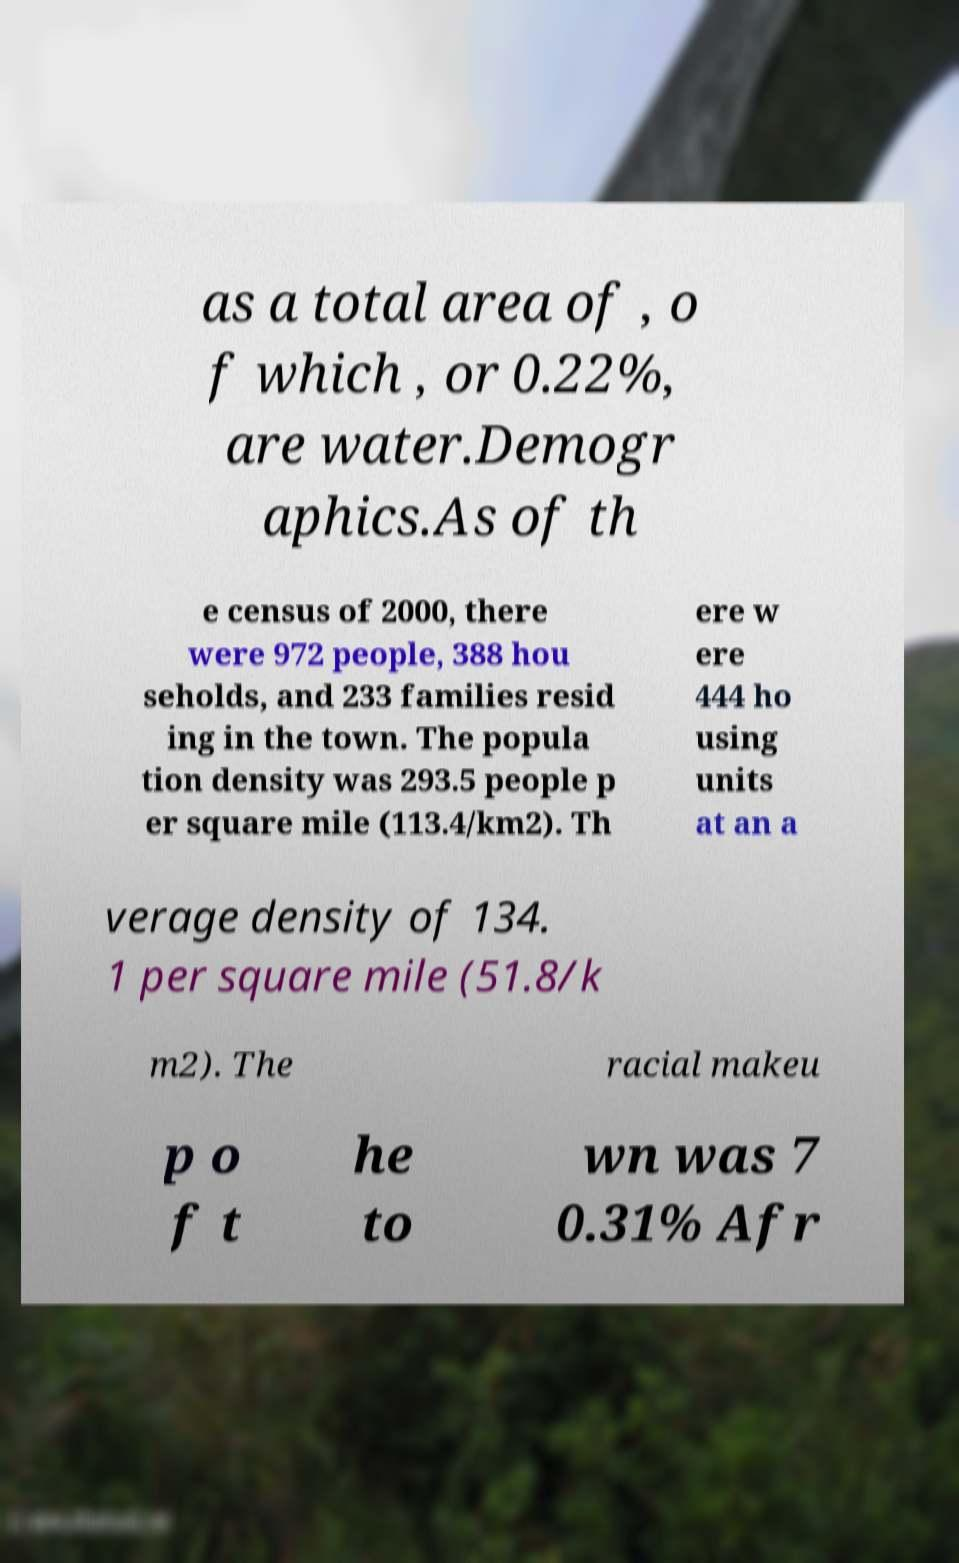There's text embedded in this image that I need extracted. Can you transcribe it verbatim? as a total area of , o f which , or 0.22%, are water.Demogr aphics.As of th e census of 2000, there were 972 people, 388 hou seholds, and 233 families resid ing in the town. The popula tion density was 293.5 people p er square mile (113.4/km2). Th ere w ere 444 ho using units at an a verage density of 134. 1 per square mile (51.8/k m2). The racial makeu p o f t he to wn was 7 0.31% Afr 